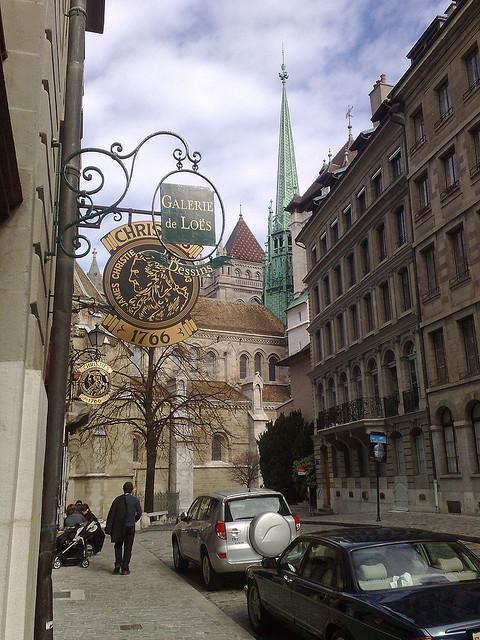Where is there most likely to be a baby at in this picture?
Make your selection from the four choices given to correctly answer the question.
Options: Stroller, building, car, tree. Stroller. 